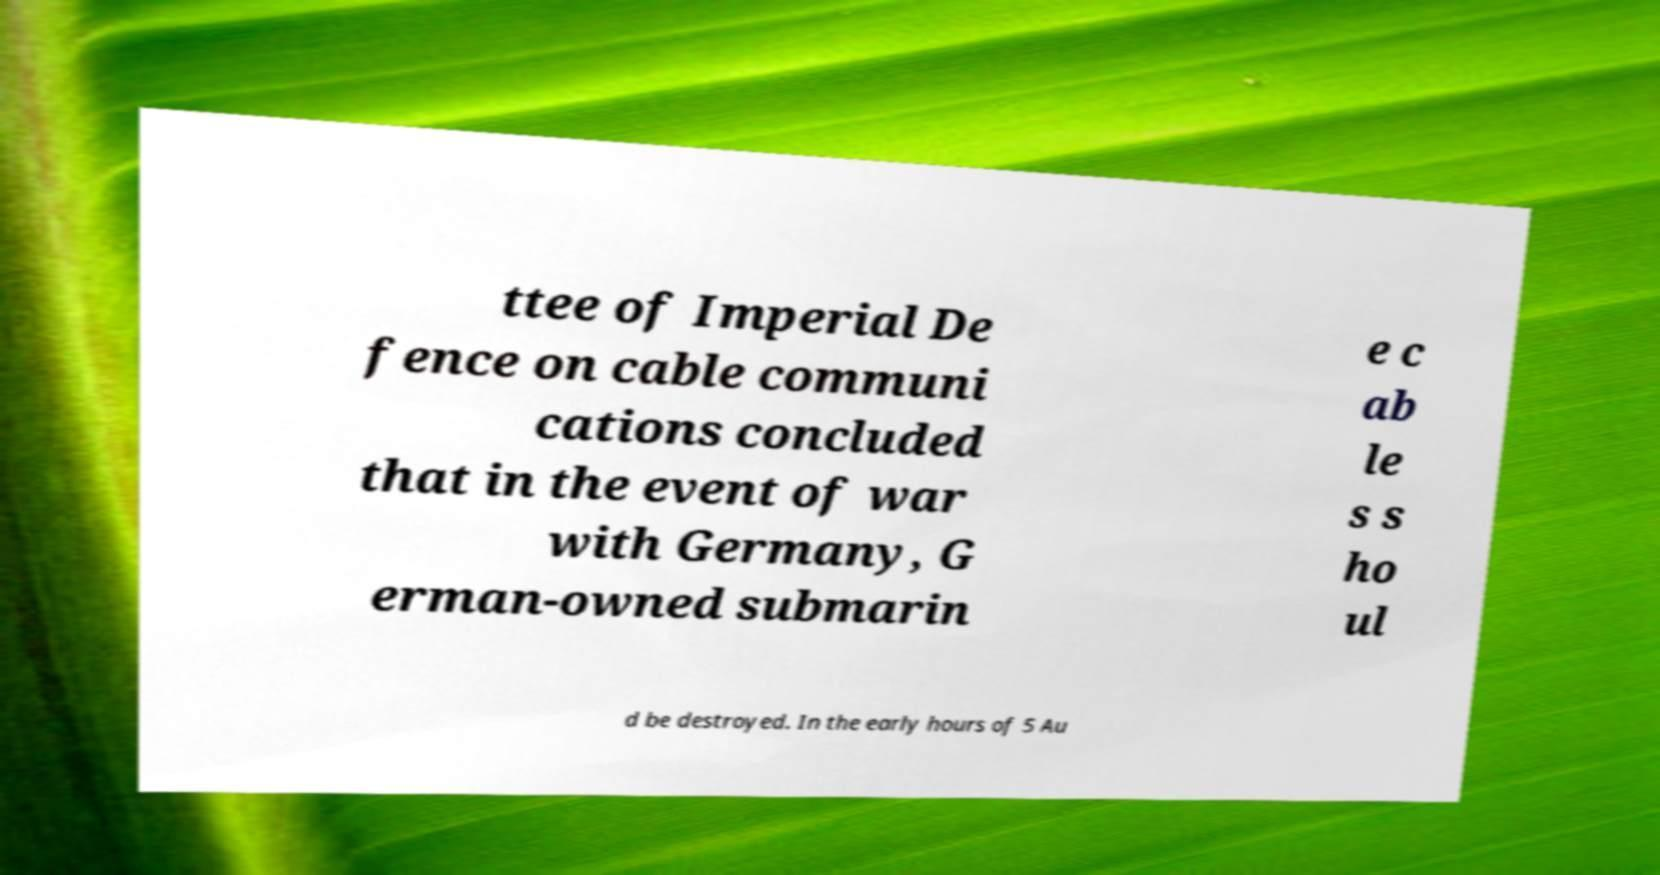There's text embedded in this image that I need extracted. Can you transcribe it verbatim? ttee of Imperial De fence on cable communi cations concluded that in the event of war with Germany, G erman-owned submarin e c ab le s s ho ul d be destroyed. In the early hours of 5 Au 